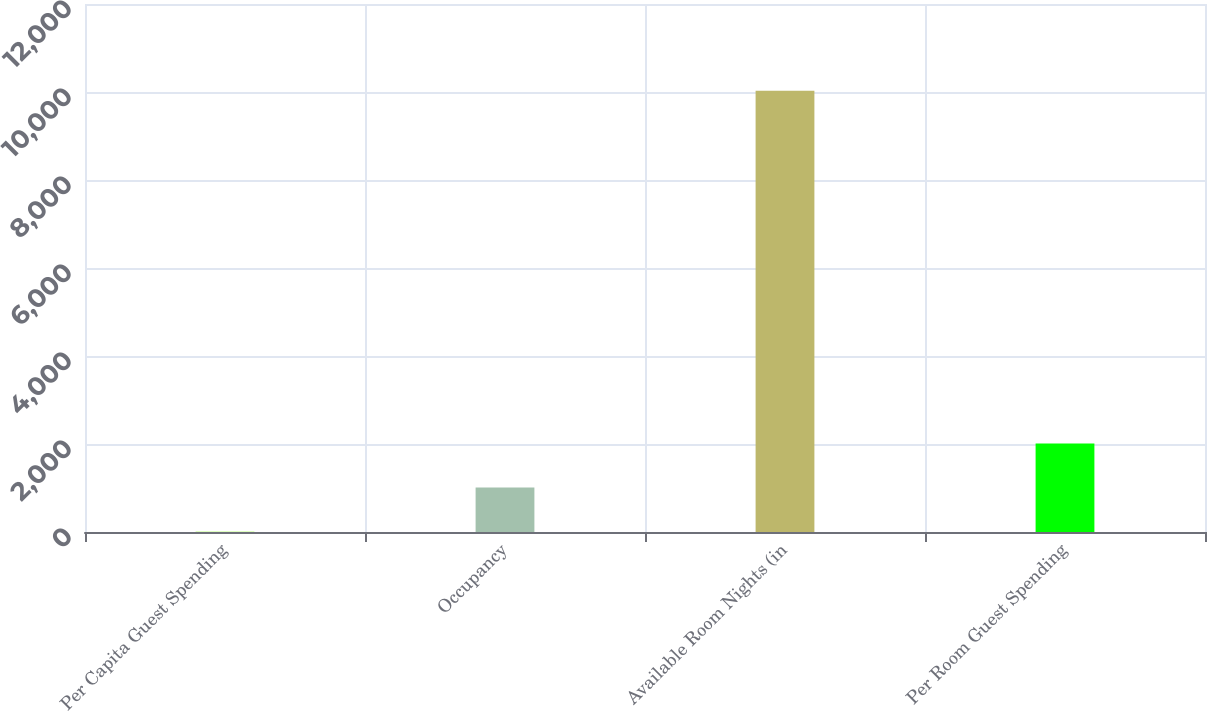Convert chart. <chart><loc_0><loc_0><loc_500><loc_500><bar_chart><fcel>Per Capita Guest Spending<fcel>Occupancy<fcel>Available Room Nights (in<fcel>Per Room Guest Spending<nl><fcel>7<fcel>1009.3<fcel>10030<fcel>2011.6<nl></chart> 